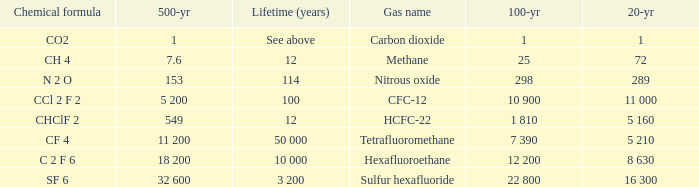What is the 100 year for Carbon Dioxide? 1.0. 